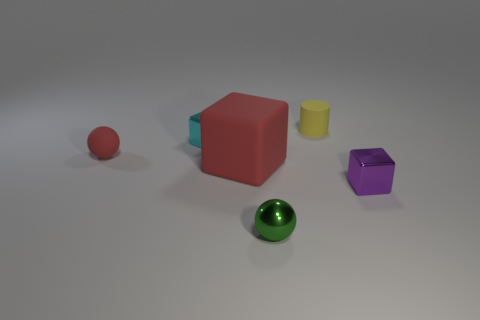Is there any other thing that is the same size as the red block?
Keep it short and to the point. No. How many cyan objects are blocks or small spheres?
Ensure brevity in your answer.  1. Do the metallic thing that is behind the large red cube and the sphere behind the small purple shiny cube have the same size?
Give a very brief answer. Yes. What number of objects are either red objects or spheres?
Offer a very short reply. 3. Is there a large red object of the same shape as the green thing?
Your response must be concise. No. Are there fewer red matte things than tiny green objects?
Provide a short and direct response. No. Is the shape of the tiny purple thing the same as the green thing?
Offer a very short reply. No. What number of things are either tiny spheres or blocks that are to the left of the tiny yellow thing?
Your response must be concise. 4. How many large blue metallic blocks are there?
Make the answer very short. 0. Are there any other objects of the same size as the cyan metal thing?
Keep it short and to the point. Yes. 